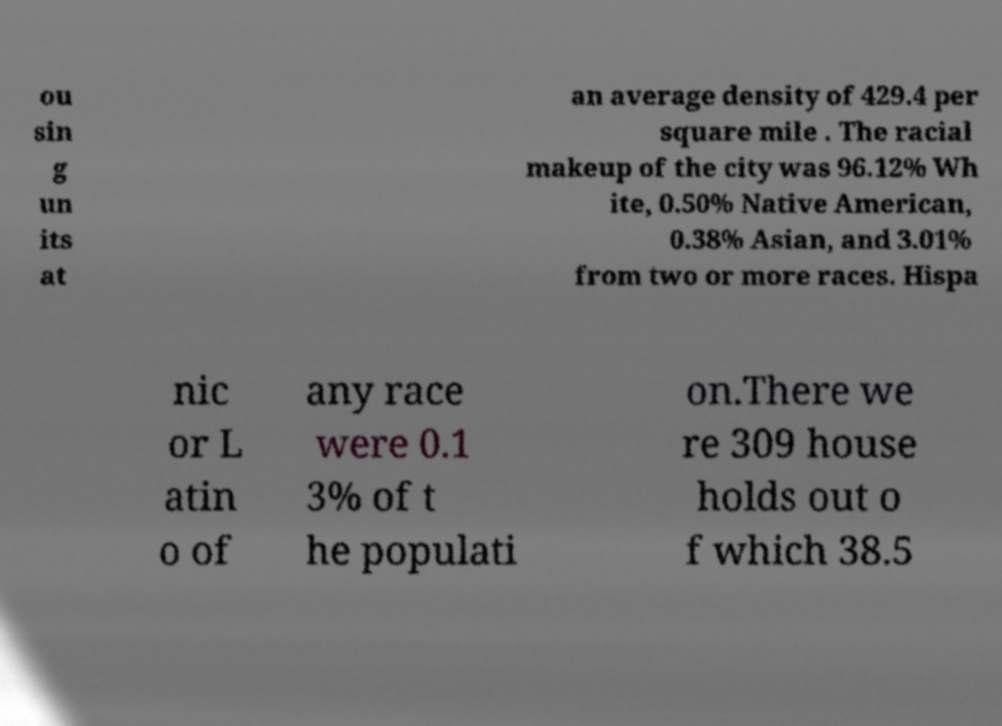Could you extract and type out the text from this image? ou sin g un its at an average density of 429.4 per square mile . The racial makeup of the city was 96.12% Wh ite, 0.50% Native American, 0.38% Asian, and 3.01% from two or more races. Hispa nic or L atin o of any race were 0.1 3% of t he populati on.There we re 309 house holds out o f which 38.5 